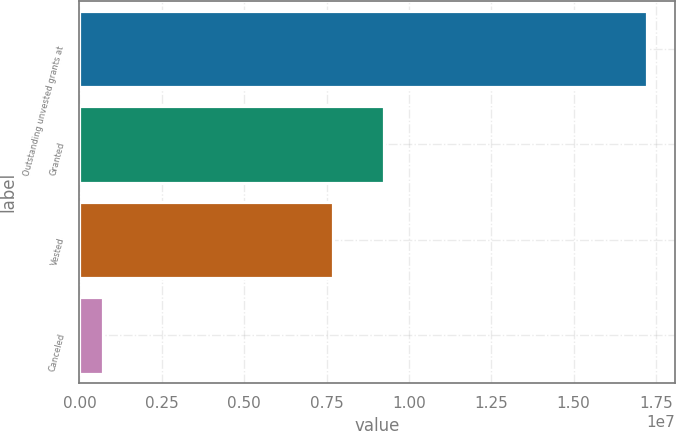<chart> <loc_0><loc_0><loc_500><loc_500><bar_chart><fcel>Outstanding unvested grants at<fcel>Granted<fcel>Vested<fcel>Canceled<nl><fcel>1.72264e+07<fcel>9.24408e+06<fcel>7.69758e+06<fcel>705542<nl></chart> 